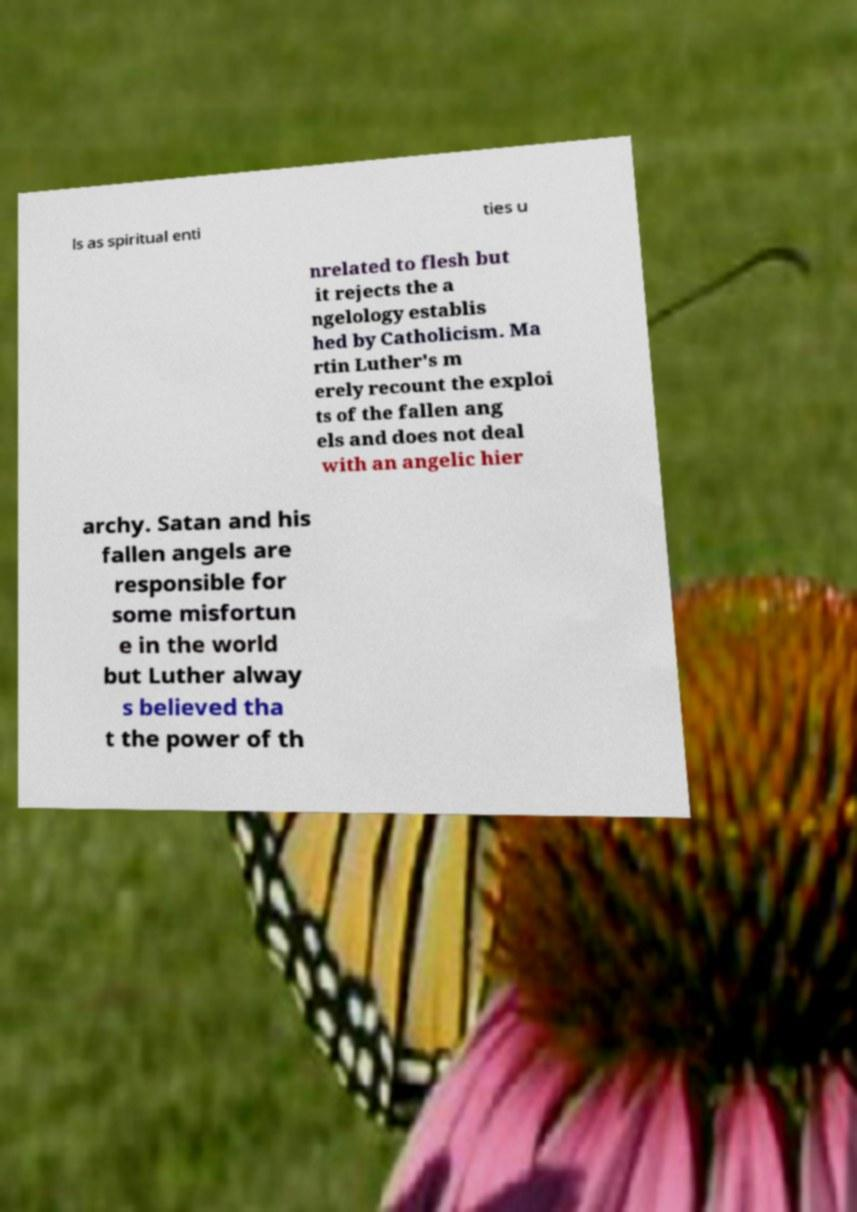For documentation purposes, I need the text within this image transcribed. Could you provide that? ls as spiritual enti ties u nrelated to flesh but it rejects the a ngelology establis hed by Catholicism. Ma rtin Luther's m erely recount the exploi ts of the fallen ang els and does not deal with an angelic hier archy. Satan and his fallen angels are responsible for some misfortun e in the world but Luther alway s believed tha t the power of th 